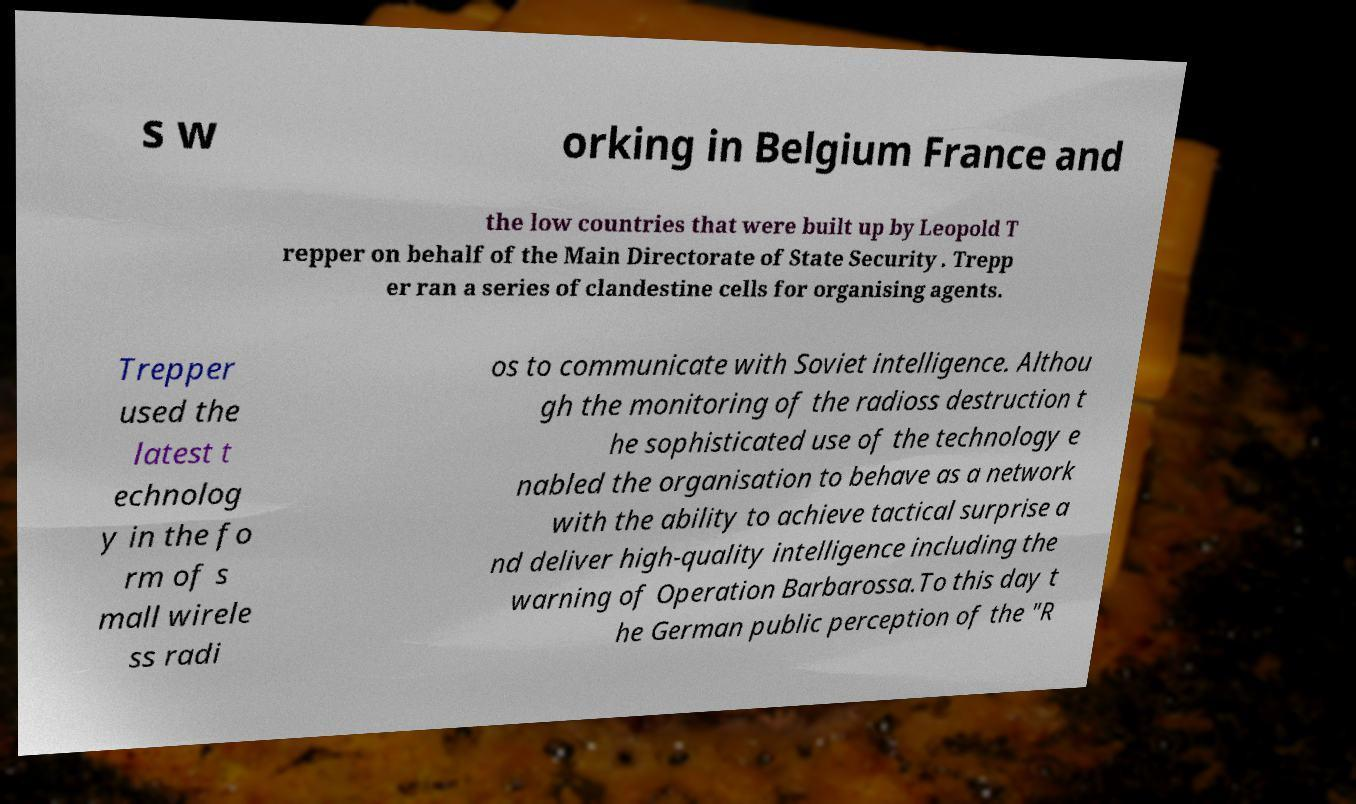Can you accurately transcribe the text from the provided image for me? s w orking in Belgium France and the low countries that were built up by Leopold T repper on behalf of the Main Directorate of State Security . Trepp er ran a series of clandestine cells for organising agents. Trepper used the latest t echnolog y in the fo rm of s mall wirele ss radi os to communicate with Soviet intelligence. Althou gh the monitoring of the radioss destruction t he sophisticated use of the technology e nabled the organisation to behave as a network with the ability to achieve tactical surprise a nd deliver high-quality intelligence including the warning of Operation Barbarossa.To this day t he German public perception of the "R 